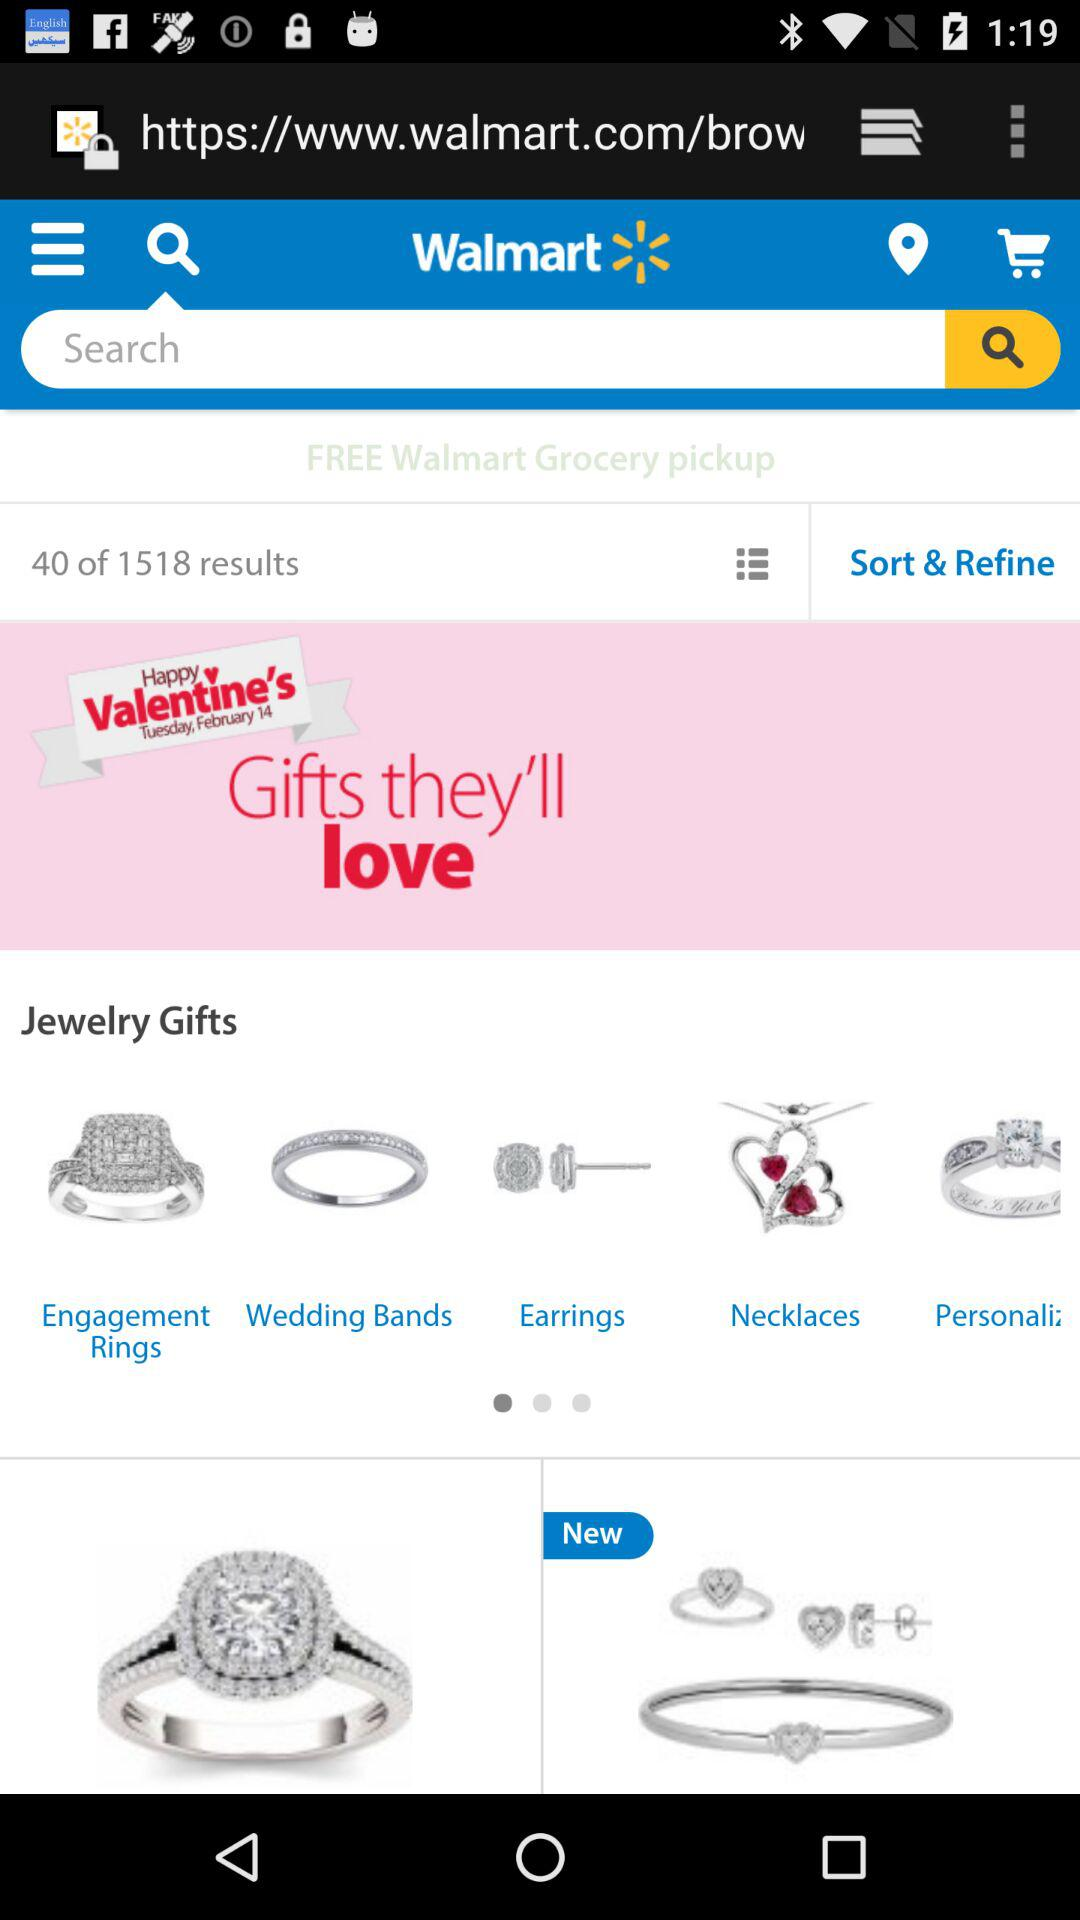What shopping website is open? The shopping website open is Walmart. 